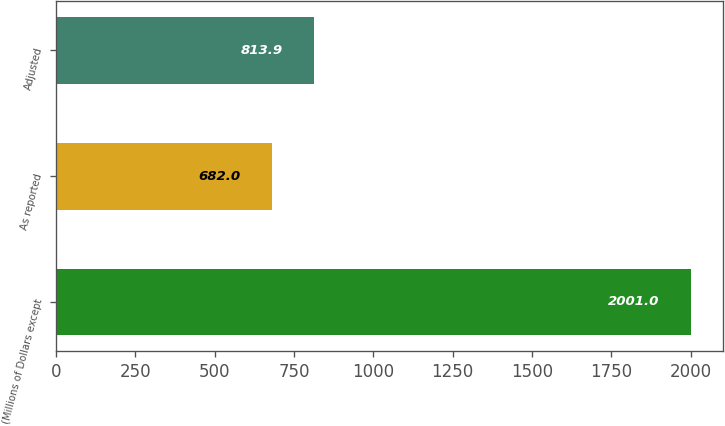<chart> <loc_0><loc_0><loc_500><loc_500><bar_chart><fcel>(Millions of Dollars except<fcel>As reported<fcel>Adjusted<nl><fcel>2001<fcel>682<fcel>813.9<nl></chart> 